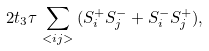Convert formula to latex. <formula><loc_0><loc_0><loc_500><loc_500>2 t _ { 3 } \tau \, \sum _ { < i j > } \, ( S _ { i } ^ { + } S _ { j } ^ { - } + S _ { i } ^ { - } S _ { j } ^ { + } ) ,</formula> 